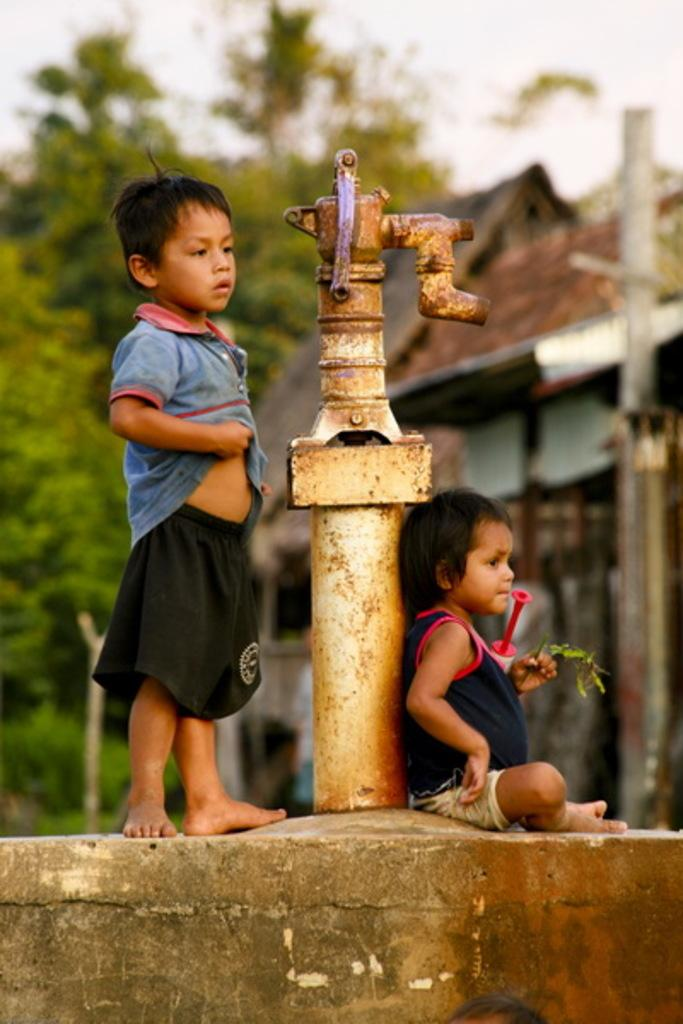How many people are in the image? There are two people in the image. What else can be seen in the image besides the people? There is a water pipe, a house, trees, and the sky visible in the image. What type of friends are observing the start of the race in the image? There is no race or friends present in the image. 